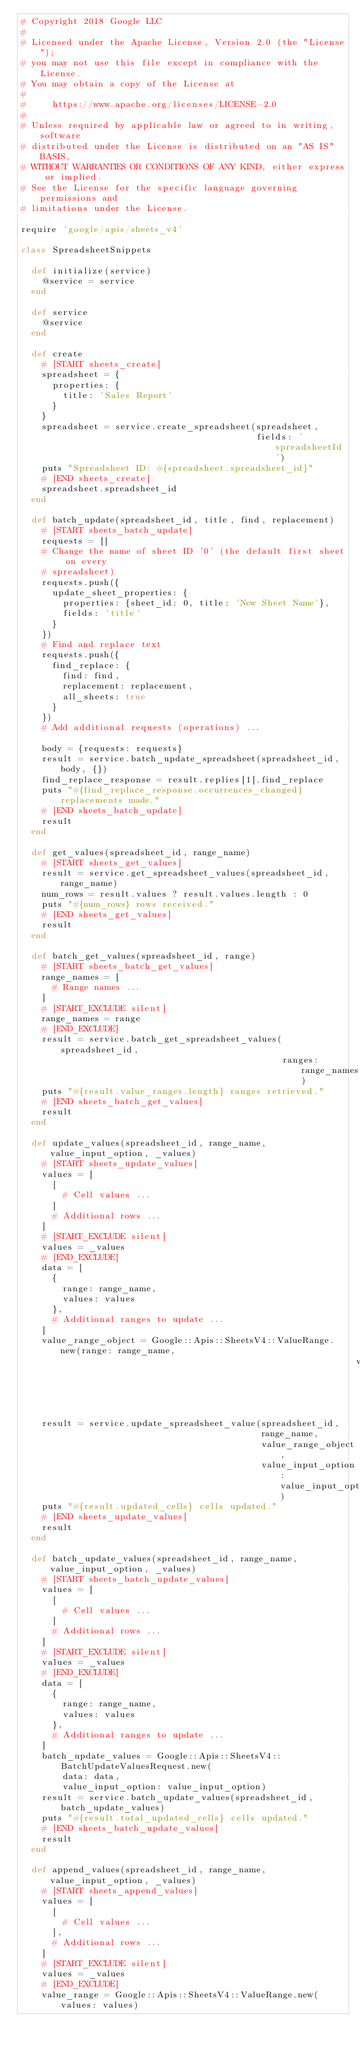Convert code to text. <code><loc_0><loc_0><loc_500><loc_500><_Ruby_># Copyright 2018 Google LLC
#
# Licensed under the Apache License, Version 2.0 (the "License");
# you may not use this file except in compliance with the License.
# You may obtain a copy of the License at
#
#     https://www.apache.org/licenses/LICENSE-2.0
#
# Unless required by applicable law or agreed to in writing, software
# distributed under the License is distributed on an "AS IS" BASIS,
# WITHOUT WARRANTIES OR CONDITIONS OF ANY KIND, either express or implied.
# See the License for the specific language governing permissions and
# limitations under the License.

require 'google/apis/sheets_v4'

class SpreadsheetSnippets

  def initialize(service)
    @service = service
  end

  def service
    @service
  end

  def create
    # [START sheets_create]
    spreadsheet = {
      properties: {
        title: 'Sales Report'
      }
    }
    spreadsheet = service.create_spreadsheet(spreadsheet,
                                             fields: 'spreadsheetId')
    puts "Spreadsheet ID: #{spreadsheet.spreadsheet_id}"
    # [END sheets_create]
    spreadsheet.spreadsheet_id
  end

  def batch_update(spreadsheet_id, title, find, replacement)
    # [START sheets_batch_update]
    requests = []
    # Change the name of sheet ID '0' (the default first sheet on every
    # spreadsheet)
    requests.push({
      update_sheet_properties: {
        properties: {sheet_id: 0, title: 'New Sheet Name'},
        fields: 'title'
      }
    })
    # Find and replace text
    requests.push({
      find_replace: {
        find: find,
        replacement: replacement,
        all_sheets: true
      }
    })
    # Add additional requests (operations) ...

    body = {requests: requests}
    result = service.batch_update_spreadsheet(spreadsheet_id, body, {})
    find_replace_response = result.replies[1].find_replace
    puts "#{find_replace_response.occurrences_changed} replacements made."
    # [END sheets_batch_update]
    result
  end

  def get_values(spreadsheet_id, range_name)
    # [START sheets_get_values]
    result = service.get_spreadsheet_values(spreadsheet_id, range_name)
    num_rows = result.values ? result.values.length : 0
    puts "#{num_rows} rows received."
    # [END sheets_get_values]
    result
  end

  def batch_get_values(spreadsheet_id, range)
    # [START sheets_batch_get_values]
    range_names = [
      # Range names ...
    ]
    # [START_EXCLUDE silent]
    range_names = range
    # [END_EXCLUDE]
    result = service.batch_get_spreadsheet_values(spreadsheet_id,
                                                  ranges: range_names)
    puts "#{result.value_ranges.length} ranges retrieved."
    # [END sheets_batch_get_values]
    result
  end

  def update_values(spreadsheet_id, range_name, value_input_option, _values)
    # [START sheets_update_values]
    values = [
      [
        # Cell values ...
      ]
      # Additional rows ...
    ]
    # [START_EXCLUDE silent]
    values = _values
    # [END_EXCLUDE]
    data = [
      {
        range: range_name,
        values: values
      },
      # Additional ranges to update ...
    ]
    value_range_object = Google::Apis::SheetsV4::ValueRange.new(range: range_name,
                                                                values: values)
    result = service.update_spreadsheet_value(spreadsheet_id,
                                              range_name,
                                              value_range_object,
                                              value_input_option: value_input_option)
    puts "#{result.updated_cells} cells updated."
    # [END sheets_update_values]
    result
  end

  def batch_update_values(spreadsheet_id, range_name, value_input_option, _values)
    # [START sheets_batch_update_values]
    values = [
      [
        # Cell values ...
      ]
      # Additional rows ...
    ]
    # [START_EXCLUDE silent]
    values = _values
    # [END_EXCLUDE]
    data = [
      {
        range: range_name,
        values: values
      },
      # Additional ranges to update ...
    ]
    batch_update_values = Google::Apis::SheetsV4::BatchUpdateValuesRequest.new(
        data: data,
        value_input_option: value_input_option)
    result = service.batch_update_values(spreadsheet_id, batch_update_values)
    puts "#{result.total_updated_cells} cells updated."
    # [END sheets_batch_update_values]
    result
  end

  def append_values(spreadsheet_id, range_name, value_input_option, _values)
    # [START sheets_append_values]
    values = [
      [
        # Cell values ...
      ],
      # Additional rows ...
    ]
    # [START_EXCLUDE silent]
    values = _values
    # [END_EXCLUDE]
    value_range = Google::Apis::SheetsV4::ValueRange.new(values: values)</code> 